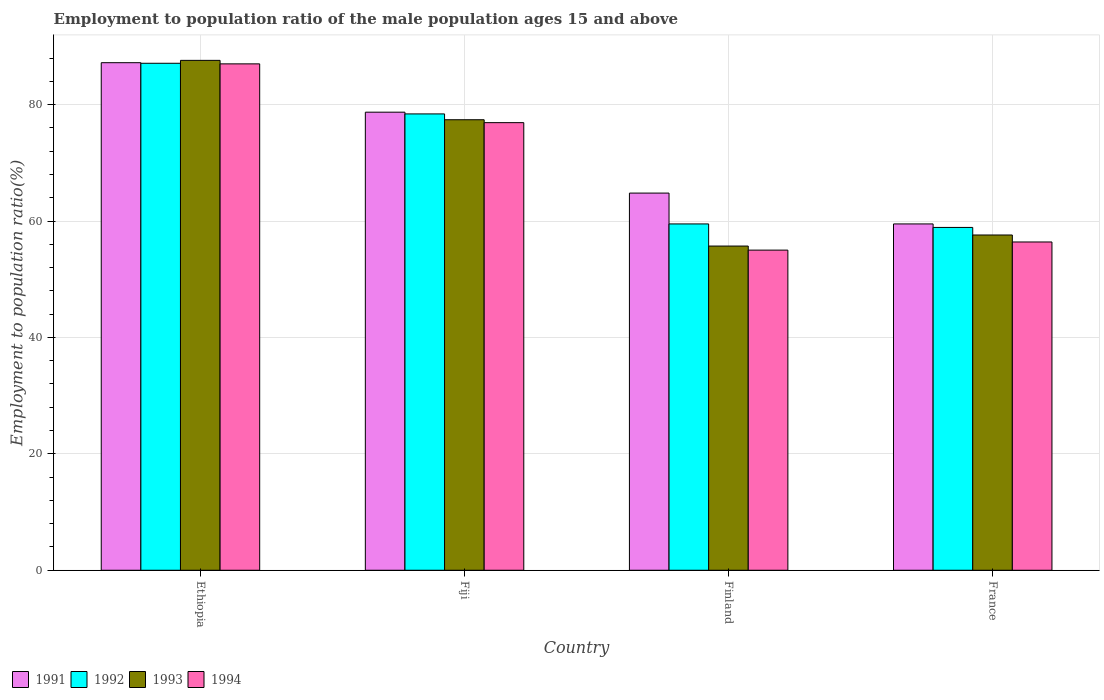Are the number of bars per tick equal to the number of legend labels?
Offer a very short reply. Yes. How many bars are there on the 2nd tick from the left?
Your response must be concise. 4. What is the label of the 2nd group of bars from the left?
Give a very brief answer. Fiji. What is the employment to population ratio in 1992 in Ethiopia?
Offer a terse response. 87.1. Across all countries, what is the maximum employment to population ratio in 1993?
Offer a very short reply. 87.6. Across all countries, what is the minimum employment to population ratio in 1991?
Offer a terse response. 59.5. In which country was the employment to population ratio in 1993 maximum?
Give a very brief answer. Ethiopia. In which country was the employment to population ratio in 1991 minimum?
Provide a short and direct response. France. What is the total employment to population ratio in 1994 in the graph?
Your answer should be very brief. 275.3. What is the difference between the employment to population ratio in 1994 in Ethiopia and that in France?
Offer a terse response. 30.6. What is the difference between the employment to population ratio in 1994 in Ethiopia and the employment to population ratio in 1993 in Finland?
Offer a terse response. 31.3. What is the average employment to population ratio in 1991 per country?
Offer a very short reply. 72.55. What is the difference between the employment to population ratio of/in 1993 and employment to population ratio of/in 1991 in Fiji?
Provide a succinct answer. -1.3. In how many countries, is the employment to population ratio in 1994 greater than 52 %?
Offer a very short reply. 4. What is the ratio of the employment to population ratio in 1994 in Finland to that in France?
Your answer should be compact. 0.98. Is the employment to population ratio in 1992 in Ethiopia less than that in Fiji?
Ensure brevity in your answer.  No. What is the difference between the highest and the second highest employment to population ratio in 1991?
Provide a short and direct response. -13.9. What is the difference between the highest and the lowest employment to population ratio in 1993?
Your answer should be very brief. 31.9. In how many countries, is the employment to population ratio in 1993 greater than the average employment to population ratio in 1993 taken over all countries?
Your answer should be compact. 2. Is the sum of the employment to population ratio in 1994 in Finland and France greater than the maximum employment to population ratio in 1993 across all countries?
Your answer should be compact. Yes. What does the 3rd bar from the left in Finland represents?
Your answer should be very brief. 1993. Is it the case that in every country, the sum of the employment to population ratio in 1991 and employment to population ratio in 1994 is greater than the employment to population ratio in 1993?
Make the answer very short. Yes. Are all the bars in the graph horizontal?
Offer a terse response. No. How many countries are there in the graph?
Provide a succinct answer. 4. What is the difference between two consecutive major ticks on the Y-axis?
Provide a short and direct response. 20. Does the graph contain any zero values?
Your response must be concise. No. Does the graph contain grids?
Your answer should be very brief. Yes. Where does the legend appear in the graph?
Provide a succinct answer. Bottom left. How many legend labels are there?
Ensure brevity in your answer.  4. How are the legend labels stacked?
Offer a terse response. Horizontal. What is the title of the graph?
Keep it short and to the point. Employment to population ratio of the male population ages 15 and above. Does "1994" appear as one of the legend labels in the graph?
Keep it short and to the point. Yes. What is the label or title of the X-axis?
Provide a short and direct response. Country. What is the label or title of the Y-axis?
Ensure brevity in your answer.  Employment to population ratio(%). What is the Employment to population ratio(%) of 1991 in Ethiopia?
Keep it short and to the point. 87.2. What is the Employment to population ratio(%) in 1992 in Ethiopia?
Offer a terse response. 87.1. What is the Employment to population ratio(%) of 1993 in Ethiopia?
Offer a very short reply. 87.6. What is the Employment to population ratio(%) of 1994 in Ethiopia?
Your answer should be very brief. 87. What is the Employment to population ratio(%) of 1991 in Fiji?
Keep it short and to the point. 78.7. What is the Employment to population ratio(%) of 1992 in Fiji?
Keep it short and to the point. 78.4. What is the Employment to population ratio(%) in 1993 in Fiji?
Offer a terse response. 77.4. What is the Employment to population ratio(%) of 1994 in Fiji?
Make the answer very short. 76.9. What is the Employment to population ratio(%) in 1991 in Finland?
Provide a succinct answer. 64.8. What is the Employment to population ratio(%) of 1992 in Finland?
Give a very brief answer. 59.5. What is the Employment to population ratio(%) of 1993 in Finland?
Provide a short and direct response. 55.7. What is the Employment to population ratio(%) in 1994 in Finland?
Your answer should be compact. 55. What is the Employment to population ratio(%) of 1991 in France?
Your answer should be very brief. 59.5. What is the Employment to population ratio(%) in 1992 in France?
Offer a very short reply. 58.9. What is the Employment to population ratio(%) in 1993 in France?
Your answer should be very brief. 57.6. What is the Employment to population ratio(%) in 1994 in France?
Offer a very short reply. 56.4. Across all countries, what is the maximum Employment to population ratio(%) in 1991?
Your answer should be very brief. 87.2. Across all countries, what is the maximum Employment to population ratio(%) of 1992?
Your answer should be compact. 87.1. Across all countries, what is the maximum Employment to population ratio(%) of 1993?
Offer a very short reply. 87.6. Across all countries, what is the maximum Employment to population ratio(%) of 1994?
Your response must be concise. 87. Across all countries, what is the minimum Employment to population ratio(%) in 1991?
Your answer should be compact. 59.5. Across all countries, what is the minimum Employment to population ratio(%) in 1992?
Make the answer very short. 58.9. Across all countries, what is the minimum Employment to population ratio(%) in 1993?
Offer a terse response. 55.7. What is the total Employment to population ratio(%) of 1991 in the graph?
Provide a short and direct response. 290.2. What is the total Employment to population ratio(%) of 1992 in the graph?
Offer a very short reply. 283.9. What is the total Employment to population ratio(%) in 1993 in the graph?
Your answer should be very brief. 278.3. What is the total Employment to population ratio(%) in 1994 in the graph?
Make the answer very short. 275.3. What is the difference between the Employment to population ratio(%) in 1991 in Ethiopia and that in Finland?
Offer a very short reply. 22.4. What is the difference between the Employment to population ratio(%) of 1992 in Ethiopia and that in Finland?
Provide a succinct answer. 27.6. What is the difference between the Employment to population ratio(%) in 1993 in Ethiopia and that in Finland?
Your answer should be very brief. 31.9. What is the difference between the Employment to population ratio(%) of 1994 in Ethiopia and that in Finland?
Give a very brief answer. 32. What is the difference between the Employment to population ratio(%) in 1991 in Ethiopia and that in France?
Your response must be concise. 27.7. What is the difference between the Employment to population ratio(%) in 1992 in Ethiopia and that in France?
Give a very brief answer. 28.2. What is the difference between the Employment to population ratio(%) of 1993 in Ethiopia and that in France?
Provide a short and direct response. 30. What is the difference between the Employment to population ratio(%) in 1994 in Ethiopia and that in France?
Give a very brief answer. 30.6. What is the difference between the Employment to population ratio(%) of 1991 in Fiji and that in Finland?
Give a very brief answer. 13.9. What is the difference between the Employment to population ratio(%) in 1993 in Fiji and that in Finland?
Make the answer very short. 21.7. What is the difference between the Employment to population ratio(%) in 1994 in Fiji and that in Finland?
Provide a short and direct response. 21.9. What is the difference between the Employment to population ratio(%) in 1991 in Fiji and that in France?
Keep it short and to the point. 19.2. What is the difference between the Employment to population ratio(%) in 1993 in Fiji and that in France?
Make the answer very short. 19.8. What is the difference between the Employment to population ratio(%) of 1994 in Fiji and that in France?
Give a very brief answer. 20.5. What is the difference between the Employment to population ratio(%) in 1991 in Finland and that in France?
Provide a short and direct response. 5.3. What is the difference between the Employment to population ratio(%) of 1992 in Finland and that in France?
Provide a short and direct response. 0.6. What is the difference between the Employment to population ratio(%) in 1991 in Ethiopia and the Employment to population ratio(%) in 1992 in Fiji?
Your answer should be very brief. 8.8. What is the difference between the Employment to population ratio(%) of 1991 in Ethiopia and the Employment to population ratio(%) of 1994 in Fiji?
Provide a succinct answer. 10.3. What is the difference between the Employment to population ratio(%) of 1993 in Ethiopia and the Employment to population ratio(%) of 1994 in Fiji?
Your answer should be compact. 10.7. What is the difference between the Employment to population ratio(%) of 1991 in Ethiopia and the Employment to population ratio(%) of 1992 in Finland?
Offer a very short reply. 27.7. What is the difference between the Employment to population ratio(%) of 1991 in Ethiopia and the Employment to population ratio(%) of 1993 in Finland?
Provide a short and direct response. 31.5. What is the difference between the Employment to population ratio(%) in 1991 in Ethiopia and the Employment to population ratio(%) in 1994 in Finland?
Your answer should be very brief. 32.2. What is the difference between the Employment to population ratio(%) of 1992 in Ethiopia and the Employment to population ratio(%) of 1993 in Finland?
Provide a succinct answer. 31.4. What is the difference between the Employment to population ratio(%) in 1992 in Ethiopia and the Employment to population ratio(%) in 1994 in Finland?
Your response must be concise. 32.1. What is the difference between the Employment to population ratio(%) of 1993 in Ethiopia and the Employment to population ratio(%) of 1994 in Finland?
Ensure brevity in your answer.  32.6. What is the difference between the Employment to population ratio(%) of 1991 in Ethiopia and the Employment to population ratio(%) of 1992 in France?
Offer a terse response. 28.3. What is the difference between the Employment to population ratio(%) of 1991 in Ethiopia and the Employment to population ratio(%) of 1993 in France?
Keep it short and to the point. 29.6. What is the difference between the Employment to population ratio(%) of 1991 in Ethiopia and the Employment to population ratio(%) of 1994 in France?
Make the answer very short. 30.8. What is the difference between the Employment to population ratio(%) in 1992 in Ethiopia and the Employment to population ratio(%) in 1993 in France?
Provide a succinct answer. 29.5. What is the difference between the Employment to population ratio(%) of 1992 in Ethiopia and the Employment to population ratio(%) of 1994 in France?
Offer a terse response. 30.7. What is the difference between the Employment to population ratio(%) in 1993 in Ethiopia and the Employment to population ratio(%) in 1994 in France?
Give a very brief answer. 31.2. What is the difference between the Employment to population ratio(%) of 1991 in Fiji and the Employment to population ratio(%) of 1992 in Finland?
Give a very brief answer. 19.2. What is the difference between the Employment to population ratio(%) in 1991 in Fiji and the Employment to population ratio(%) in 1994 in Finland?
Provide a short and direct response. 23.7. What is the difference between the Employment to population ratio(%) in 1992 in Fiji and the Employment to population ratio(%) in 1993 in Finland?
Keep it short and to the point. 22.7. What is the difference between the Employment to population ratio(%) in 1992 in Fiji and the Employment to population ratio(%) in 1994 in Finland?
Your response must be concise. 23.4. What is the difference between the Employment to population ratio(%) in 1993 in Fiji and the Employment to population ratio(%) in 1994 in Finland?
Offer a terse response. 22.4. What is the difference between the Employment to population ratio(%) in 1991 in Fiji and the Employment to population ratio(%) in 1992 in France?
Your response must be concise. 19.8. What is the difference between the Employment to population ratio(%) in 1991 in Fiji and the Employment to population ratio(%) in 1993 in France?
Your response must be concise. 21.1. What is the difference between the Employment to population ratio(%) of 1991 in Fiji and the Employment to population ratio(%) of 1994 in France?
Your answer should be compact. 22.3. What is the difference between the Employment to population ratio(%) of 1992 in Fiji and the Employment to population ratio(%) of 1993 in France?
Ensure brevity in your answer.  20.8. What is the difference between the Employment to population ratio(%) in 1991 in Finland and the Employment to population ratio(%) in 1992 in France?
Keep it short and to the point. 5.9. What is the difference between the Employment to population ratio(%) in 1992 in Finland and the Employment to population ratio(%) in 1994 in France?
Your answer should be compact. 3.1. What is the difference between the Employment to population ratio(%) in 1993 in Finland and the Employment to population ratio(%) in 1994 in France?
Give a very brief answer. -0.7. What is the average Employment to population ratio(%) of 1991 per country?
Offer a very short reply. 72.55. What is the average Employment to population ratio(%) of 1992 per country?
Your response must be concise. 70.97. What is the average Employment to population ratio(%) in 1993 per country?
Your answer should be compact. 69.58. What is the average Employment to population ratio(%) of 1994 per country?
Make the answer very short. 68.83. What is the difference between the Employment to population ratio(%) of 1991 and Employment to population ratio(%) of 1993 in Ethiopia?
Your answer should be compact. -0.4. What is the difference between the Employment to population ratio(%) in 1991 and Employment to population ratio(%) in 1994 in Ethiopia?
Provide a short and direct response. 0.2. What is the difference between the Employment to population ratio(%) in 1992 and Employment to population ratio(%) in 1993 in Fiji?
Your answer should be very brief. 1. What is the difference between the Employment to population ratio(%) of 1992 and Employment to population ratio(%) of 1994 in Fiji?
Give a very brief answer. 1.5. What is the difference between the Employment to population ratio(%) in 1991 and Employment to population ratio(%) in 1992 in Finland?
Offer a terse response. 5.3. What is the difference between the Employment to population ratio(%) of 1992 and Employment to population ratio(%) of 1993 in Finland?
Ensure brevity in your answer.  3.8. What is the difference between the Employment to population ratio(%) in 1991 and Employment to population ratio(%) in 1993 in France?
Ensure brevity in your answer.  1.9. What is the difference between the Employment to population ratio(%) in 1991 and Employment to population ratio(%) in 1994 in France?
Keep it short and to the point. 3.1. What is the difference between the Employment to population ratio(%) of 1992 and Employment to population ratio(%) of 1993 in France?
Provide a short and direct response. 1.3. What is the ratio of the Employment to population ratio(%) of 1991 in Ethiopia to that in Fiji?
Your response must be concise. 1.11. What is the ratio of the Employment to population ratio(%) of 1992 in Ethiopia to that in Fiji?
Give a very brief answer. 1.11. What is the ratio of the Employment to population ratio(%) in 1993 in Ethiopia to that in Fiji?
Give a very brief answer. 1.13. What is the ratio of the Employment to population ratio(%) in 1994 in Ethiopia to that in Fiji?
Provide a short and direct response. 1.13. What is the ratio of the Employment to population ratio(%) of 1991 in Ethiopia to that in Finland?
Your response must be concise. 1.35. What is the ratio of the Employment to population ratio(%) in 1992 in Ethiopia to that in Finland?
Provide a succinct answer. 1.46. What is the ratio of the Employment to population ratio(%) of 1993 in Ethiopia to that in Finland?
Provide a short and direct response. 1.57. What is the ratio of the Employment to population ratio(%) of 1994 in Ethiopia to that in Finland?
Your answer should be very brief. 1.58. What is the ratio of the Employment to population ratio(%) in 1991 in Ethiopia to that in France?
Your response must be concise. 1.47. What is the ratio of the Employment to population ratio(%) in 1992 in Ethiopia to that in France?
Offer a terse response. 1.48. What is the ratio of the Employment to population ratio(%) in 1993 in Ethiopia to that in France?
Provide a succinct answer. 1.52. What is the ratio of the Employment to population ratio(%) of 1994 in Ethiopia to that in France?
Your response must be concise. 1.54. What is the ratio of the Employment to population ratio(%) of 1991 in Fiji to that in Finland?
Provide a short and direct response. 1.21. What is the ratio of the Employment to population ratio(%) in 1992 in Fiji to that in Finland?
Offer a very short reply. 1.32. What is the ratio of the Employment to population ratio(%) of 1993 in Fiji to that in Finland?
Give a very brief answer. 1.39. What is the ratio of the Employment to population ratio(%) in 1994 in Fiji to that in Finland?
Provide a succinct answer. 1.4. What is the ratio of the Employment to population ratio(%) of 1991 in Fiji to that in France?
Offer a very short reply. 1.32. What is the ratio of the Employment to population ratio(%) in 1992 in Fiji to that in France?
Provide a succinct answer. 1.33. What is the ratio of the Employment to population ratio(%) in 1993 in Fiji to that in France?
Your answer should be compact. 1.34. What is the ratio of the Employment to population ratio(%) of 1994 in Fiji to that in France?
Provide a succinct answer. 1.36. What is the ratio of the Employment to population ratio(%) of 1991 in Finland to that in France?
Ensure brevity in your answer.  1.09. What is the ratio of the Employment to population ratio(%) in 1992 in Finland to that in France?
Keep it short and to the point. 1.01. What is the ratio of the Employment to population ratio(%) in 1994 in Finland to that in France?
Make the answer very short. 0.98. What is the difference between the highest and the second highest Employment to population ratio(%) in 1991?
Provide a short and direct response. 8.5. What is the difference between the highest and the second highest Employment to population ratio(%) of 1993?
Offer a terse response. 10.2. What is the difference between the highest and the lowest Employment to population ratio(%) in 1991?
Make the answer very short. 27.7. What is the difference between the highest and the lowest Employment to population ratio(%) of 1992?
Your answer should be very brief. 28.2. What is the difference between the highest and the lowest Employment to population ratio(%) of 1993?
Give a very brief answer. 31.9. 